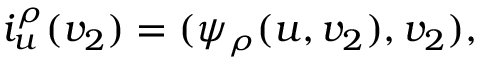Convert formula to latex. <formula><loc_0><loc_0><loc_500><loc_500>i _ { u } ^ { \rho } ( v _ { 2 } ) = ( \psi _ { \rho } ( u , v _ { 2 } ) , v _ { 2 } ) ,</formula> 